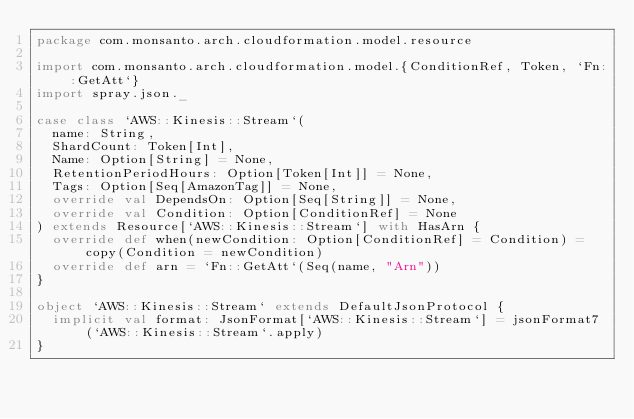Convert code to text. <code><loc_0><loc_0><loc_500><loc_500><_Scala_>package com.monsanto.arch.cloudformation.model.resource

import com.monsanto.arch.cloudformation.model.{ConditionRef, Token, `Fn::GetAtt`}
import spray.json._

case class `AWS::Kinesis::Stream`(
  name: String,
  ShardCount: Token[Int],
  Name: Option[String] = None,
  RetentionPeriodHours: Option[Token[Int]] = None,
  Tags: Option[Seq[AmazonTag]] = None,
  override val DependsOn: Option[Seq[String]] = None,
  override val Condition: Option[ConditionRef] = None
) extends Resource[`AWS::Kinesis::Stream`] with HasArn {
  override def when(newCondition: Option[ConditionRef] = Condition) = copy(Condition = newCondition)
  override def arn = `Fn::GetAtt`(Seq(name, "Arn"))
}

object `AWS::Kinesis::Stream` extends DefaultJsonProtocol {
  implicit val format: JsonFormat[`AWS::Kinesis::Stream`] = jsonFormat7(`AWS::Kinesis::Stream`.apply)
}
</code> 